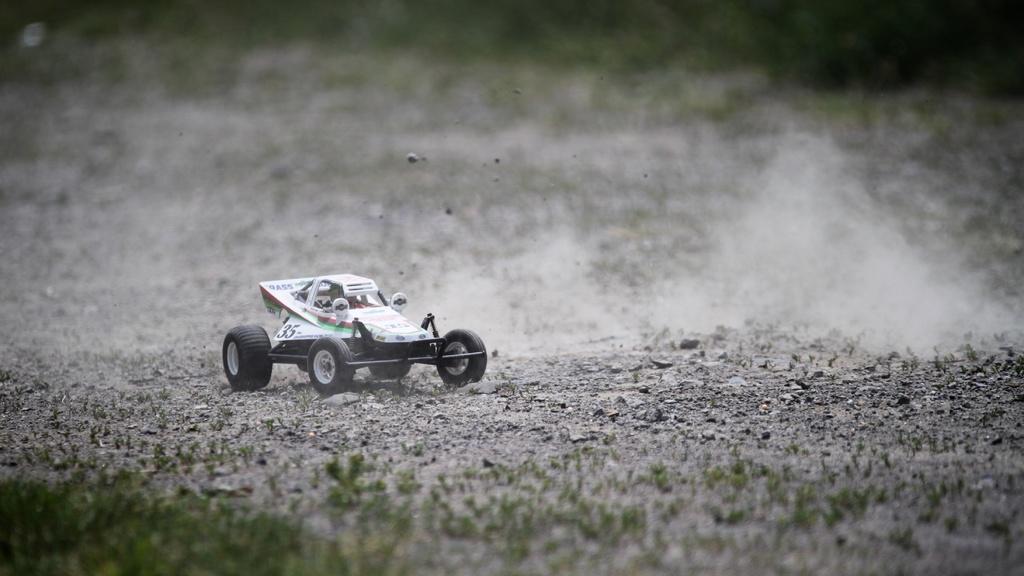Can you describe this image briefly? In this image we can see a toy vehicle on the land. At the bottom of the image, we can see the grass. 